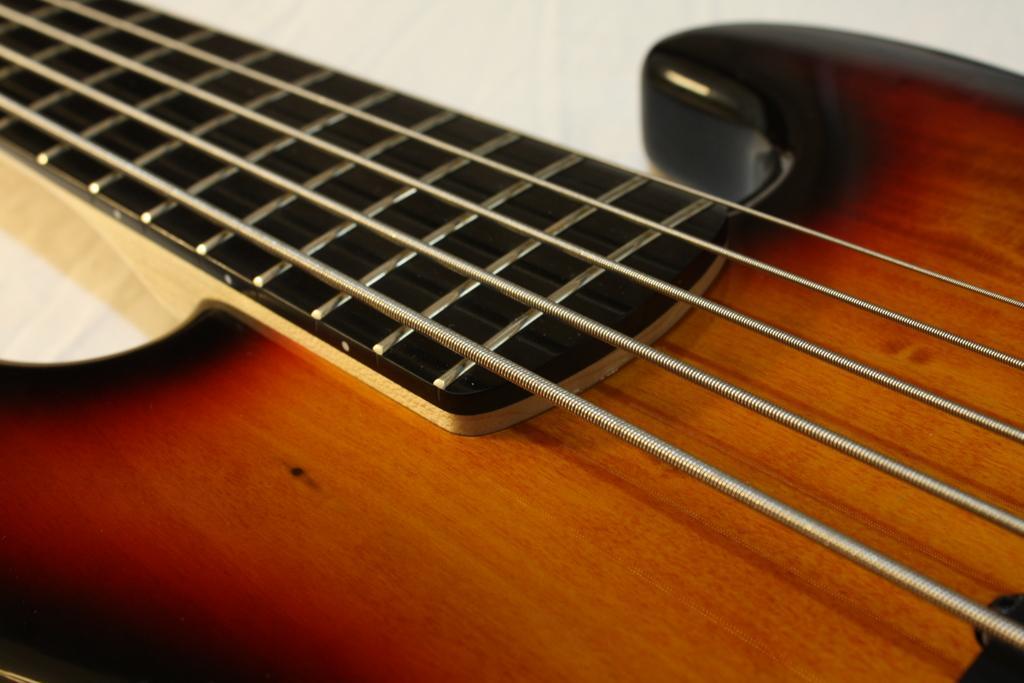Please provide a concise description of this image. In this picture there is a guitar where strings can be seen on the table or a floor. 